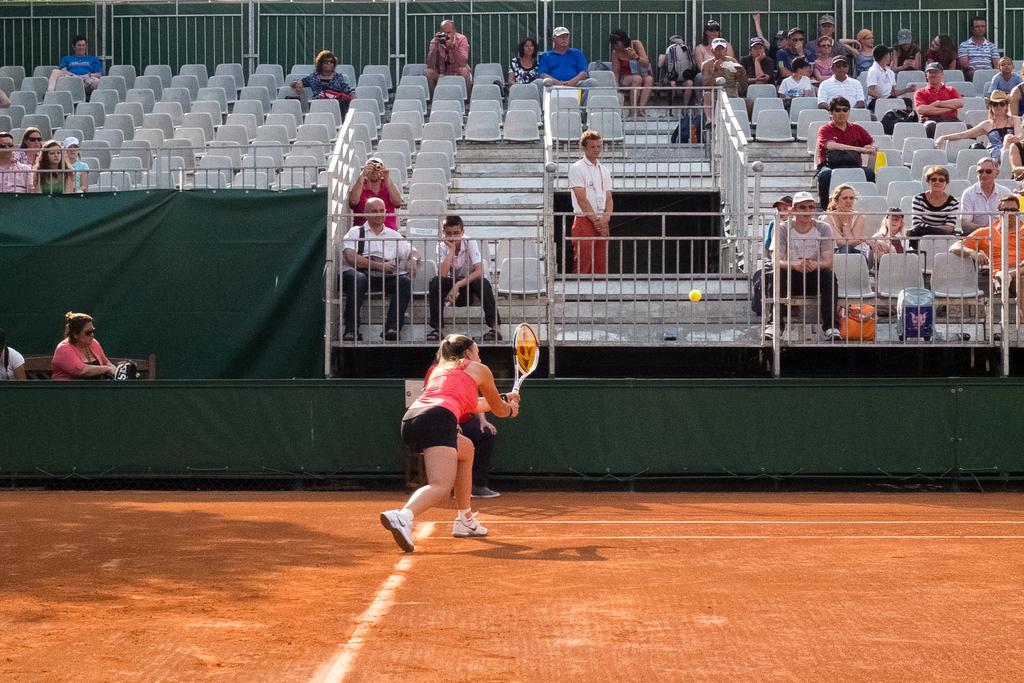What activity is the woman in the image engaged in? The woman is playing tennis in the image. Where is the tennis being played? The tennis is being played on a ground. What can be seen in the background of the image? There is a railing in the background of the image. What are the people behind the railing doing? There are people sitting on chairs behind the railing. What type of kite is being flown by the woman playing tennis in the image? There is no kite present in the image; the woman is playing tennis. 